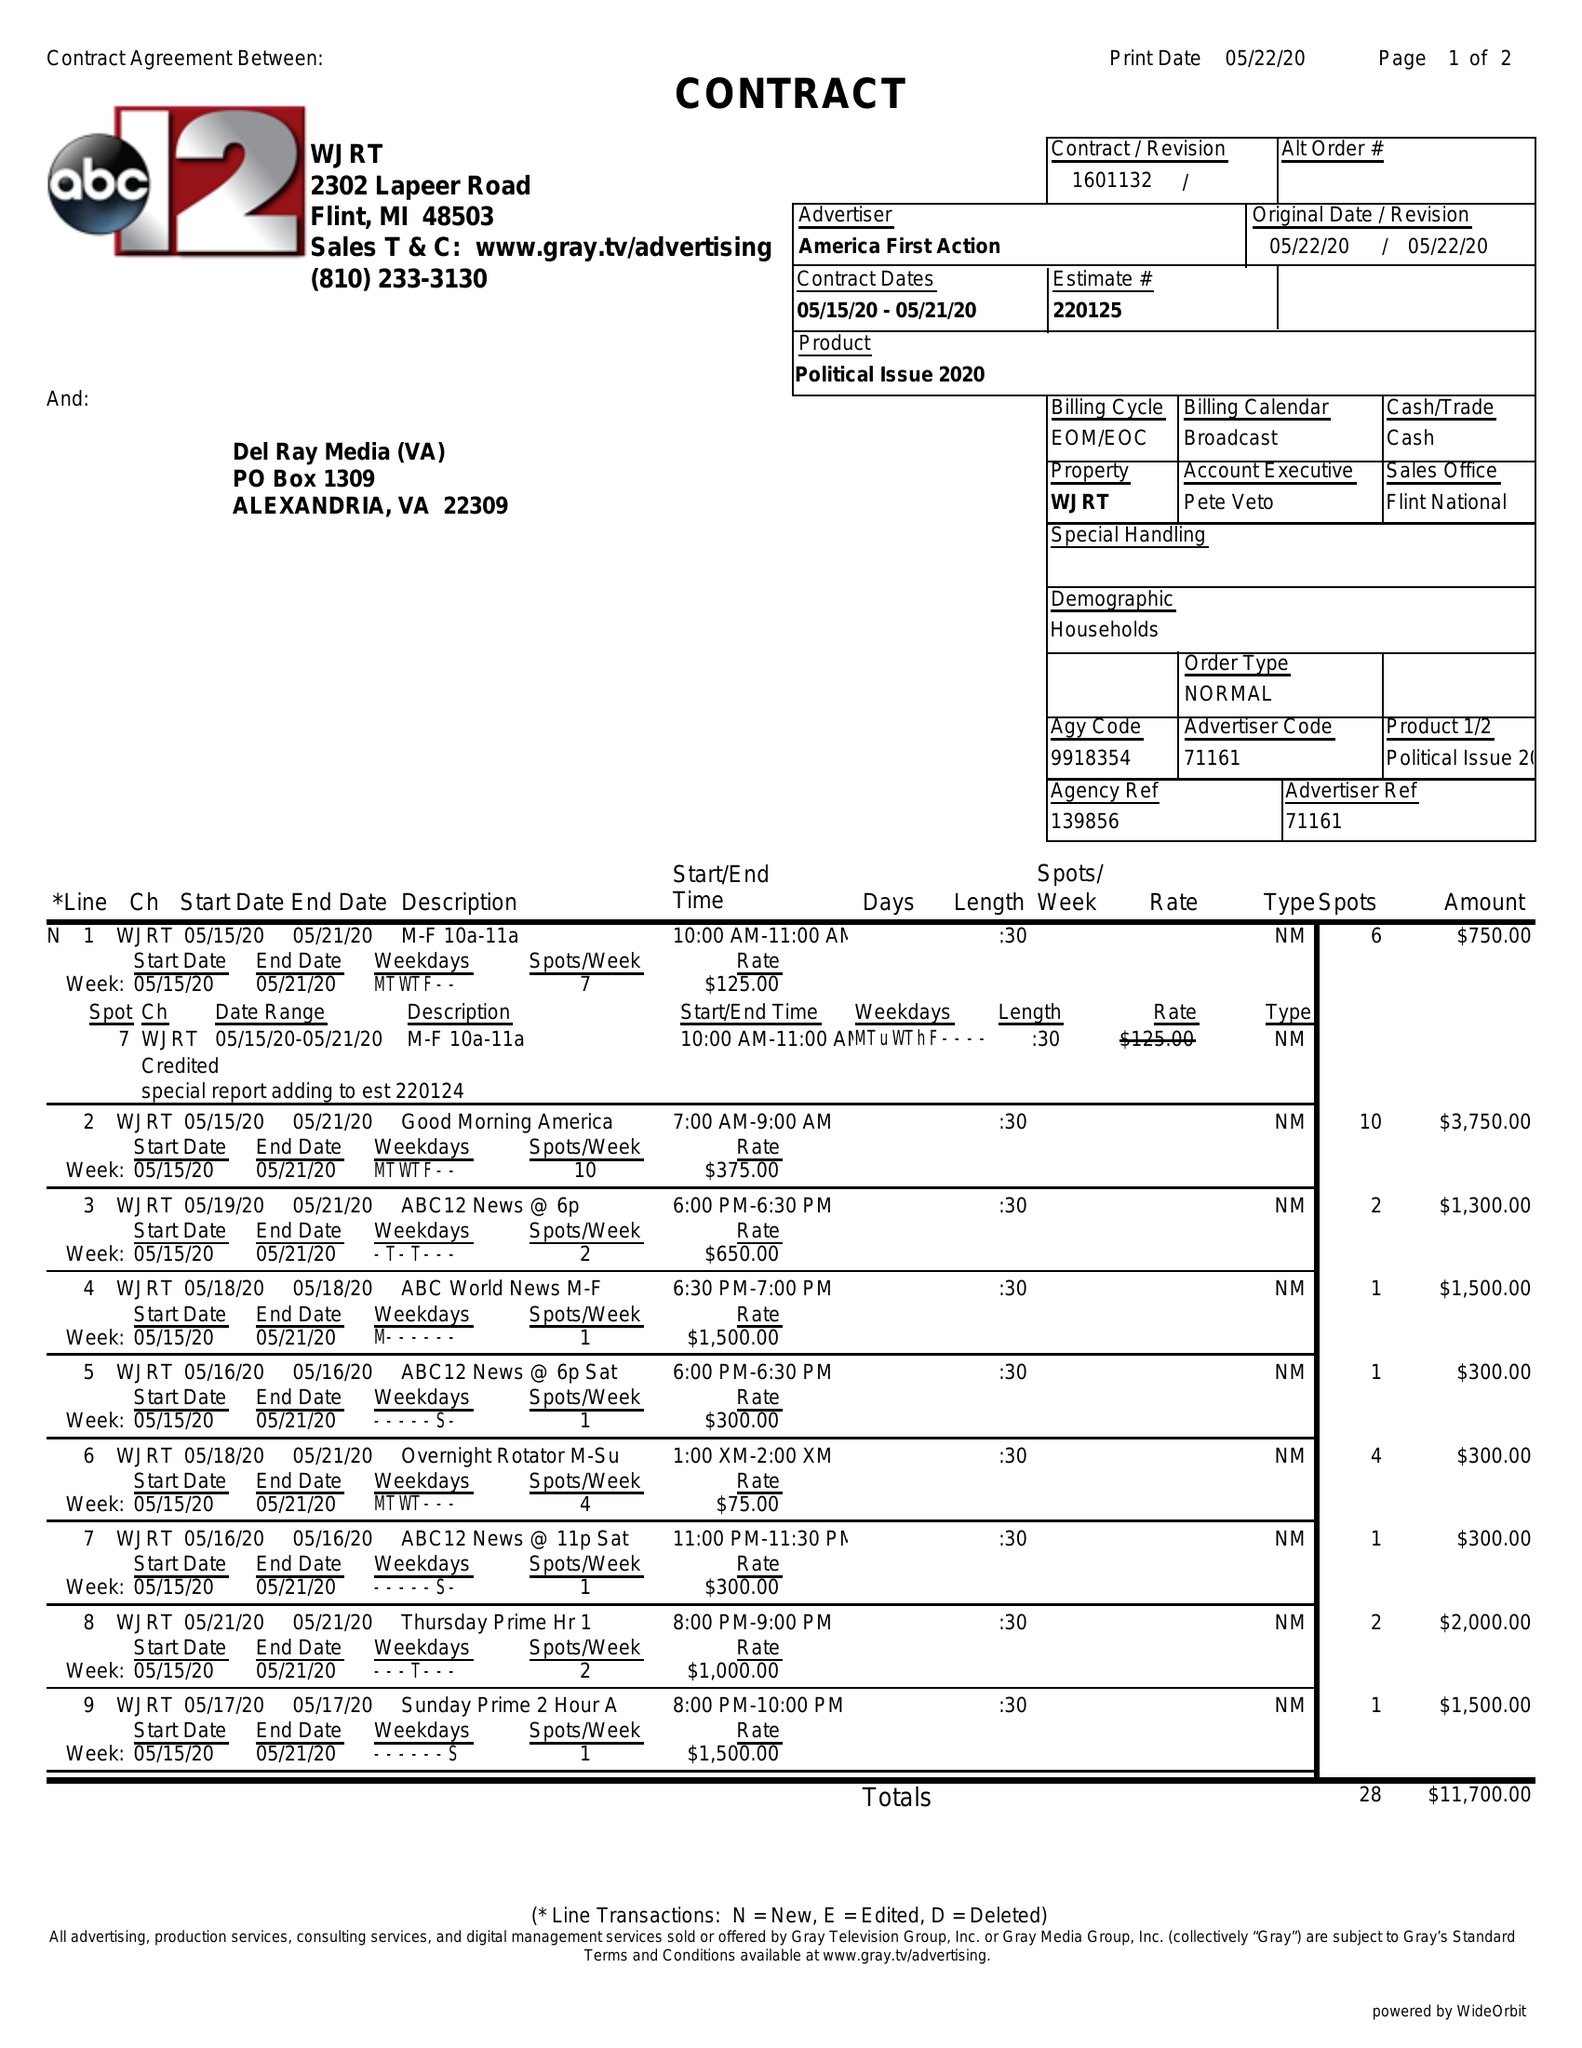What is the value for the flight_from?
Answer the question using a single word or phrase. 05/15/20 